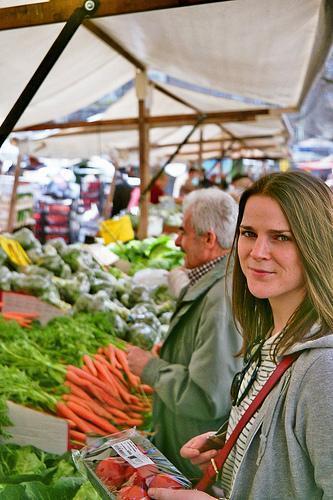How many people are there?
Give a very brief answer. 2. 